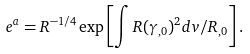Convert formula to latex. <formula><loc_0><loc_0><loc_500><loc_500>e ^ { a } = R ^ { - 1 / 4 } \exp \left [ \int R ( \gamma _ { , 0 } ) ^ { 2 } d v / R _ { , 0 } \right ] .</formula> 